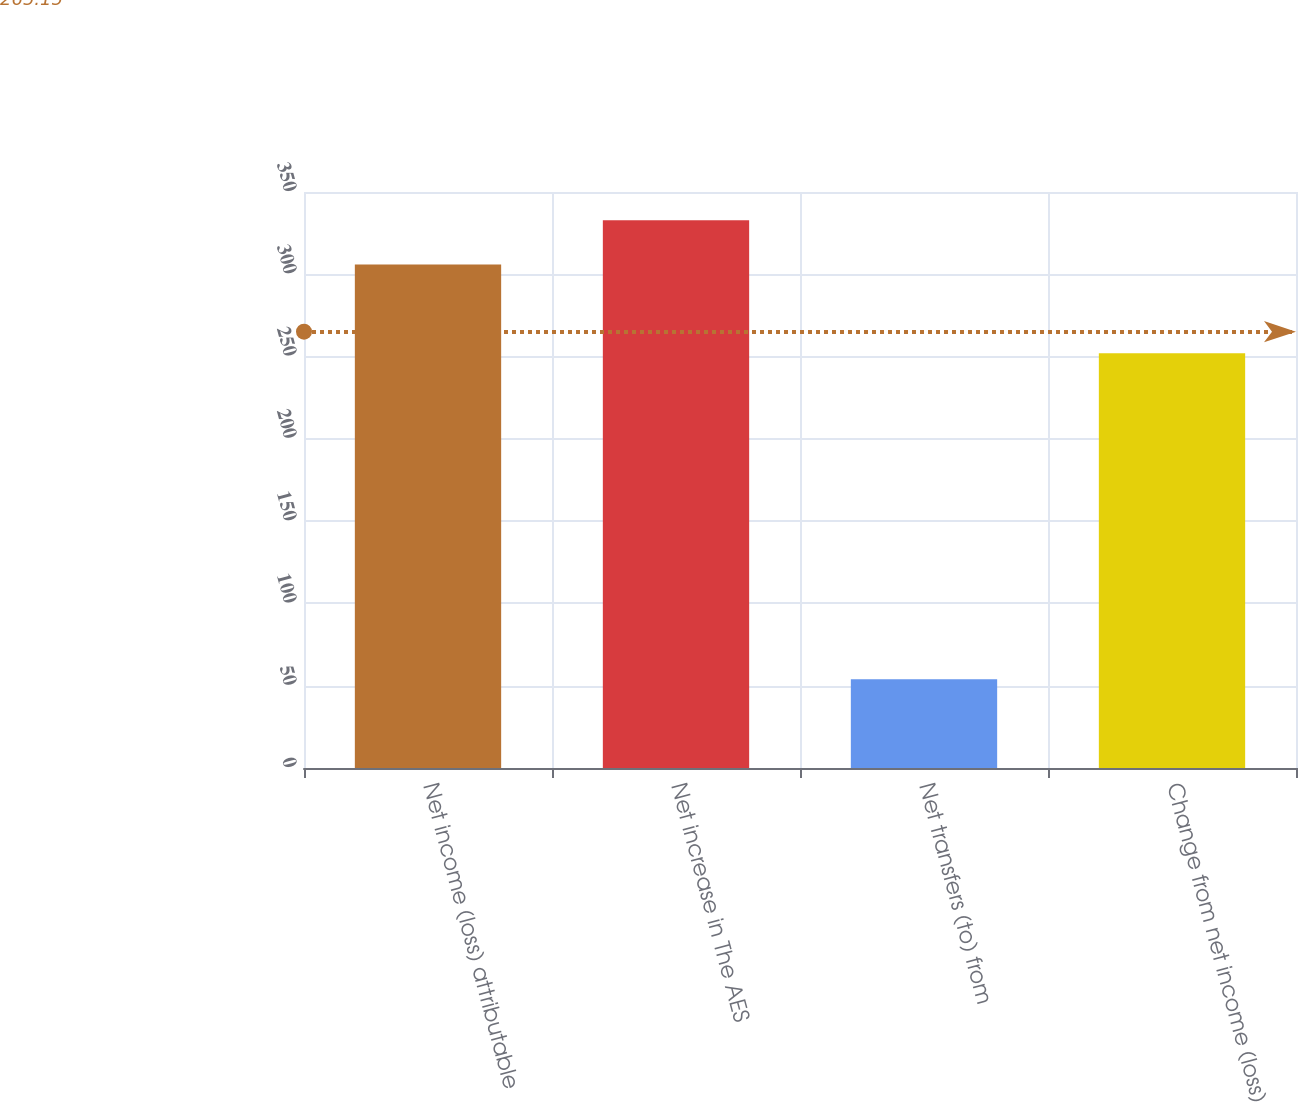Convert chart to OTSL. <chart><loc_0><loc_0><loc_500><loc_500><bar_chart><fcel>Net income (loss) attributable<fcel>Net increase in The AES<fcel>Net transfers (to) from<fcel>Change from net income (loss)<nl><fcel>306<fcel>332.9<fcel>54<fcel>252<nl></chart> 